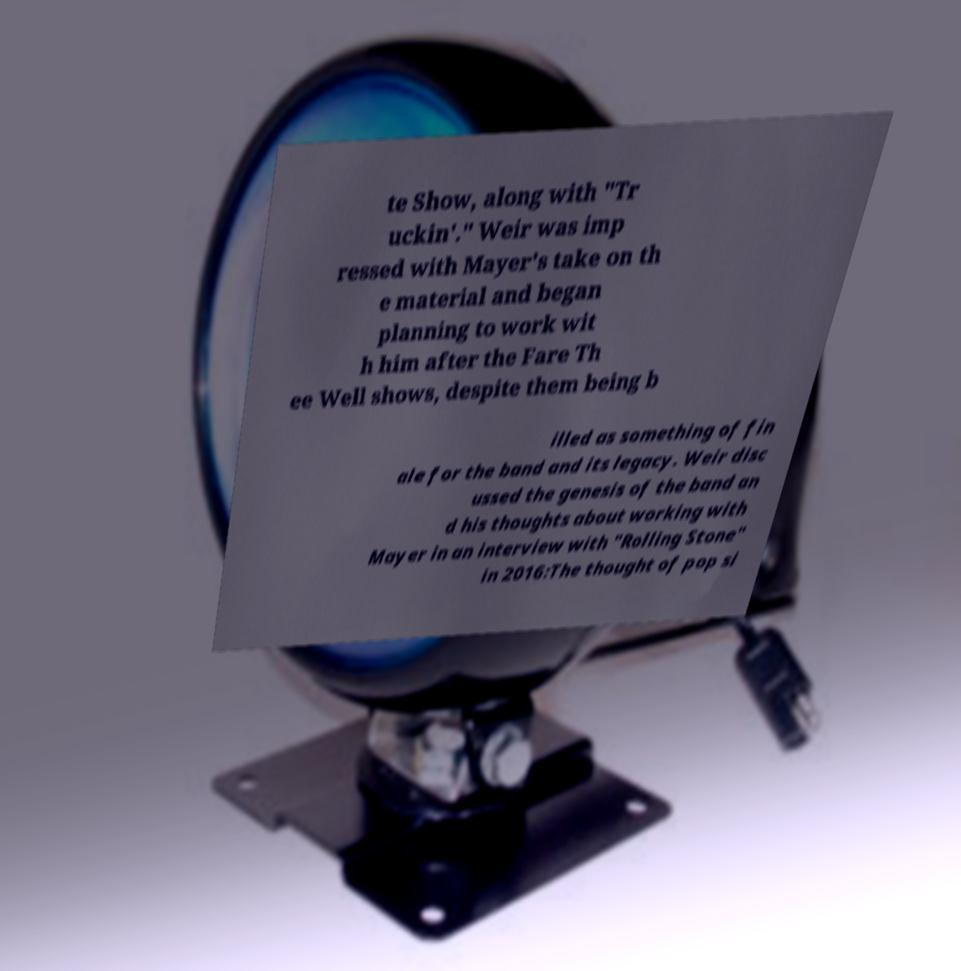Can you read and provide the text displayed in the image?This photo seems to have some interesting text. Can you extract and type it out for me? te Show, along with "Tr uckin'." Weir was imp ressed with Mayer's take on th e material and began planning to work wit h him after the Fare Th ee Well shows, despite them being b illed as something of fin ale for the band and its legacy. Weir disc ussed the genesis of the band an d his thoughts about working with Mayer in an interview with "Rolling Stone" in 2016:The thought of pop si 